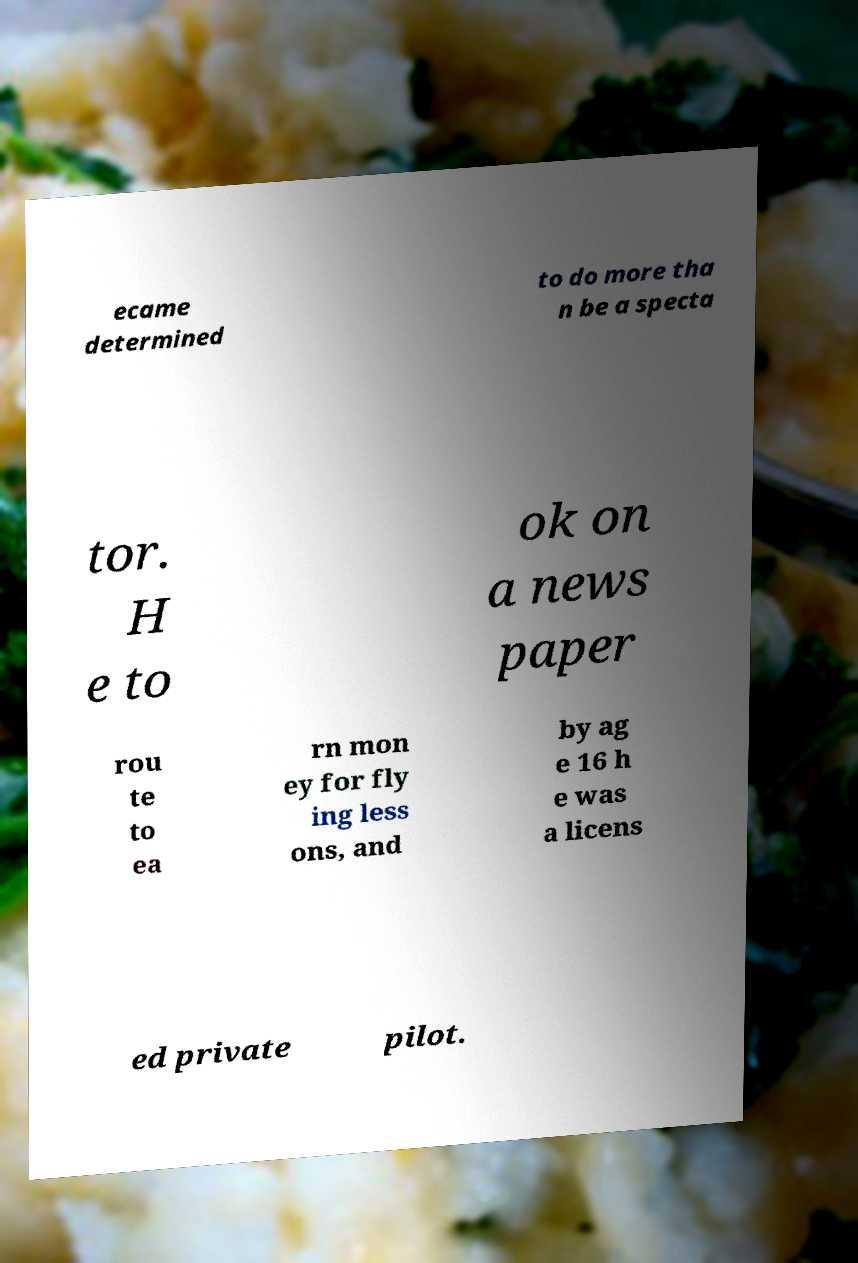Can you accurately transcribe the text from the provided image for me? ecame determined to do more tha n be a specta tor. H e to ok on a news paper rou te to ea rn mon ey for fly ing less ons, and by ag e 16 h e was a licens ed private pilot. 